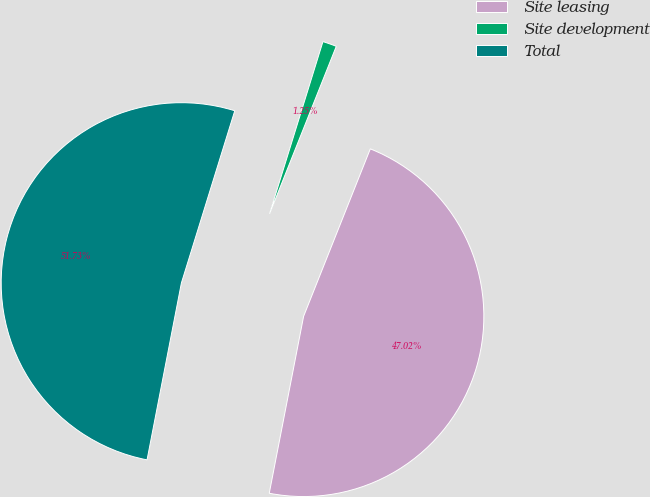<chart> <loc_0><loc_0><loc_500><loc_500><pie_chart><fcel>Site leasing<fcel>Site development<fcel>Total<nl><fcel>47.02%<fcel>1.25%<fcel>51.73%<nl></chart> 